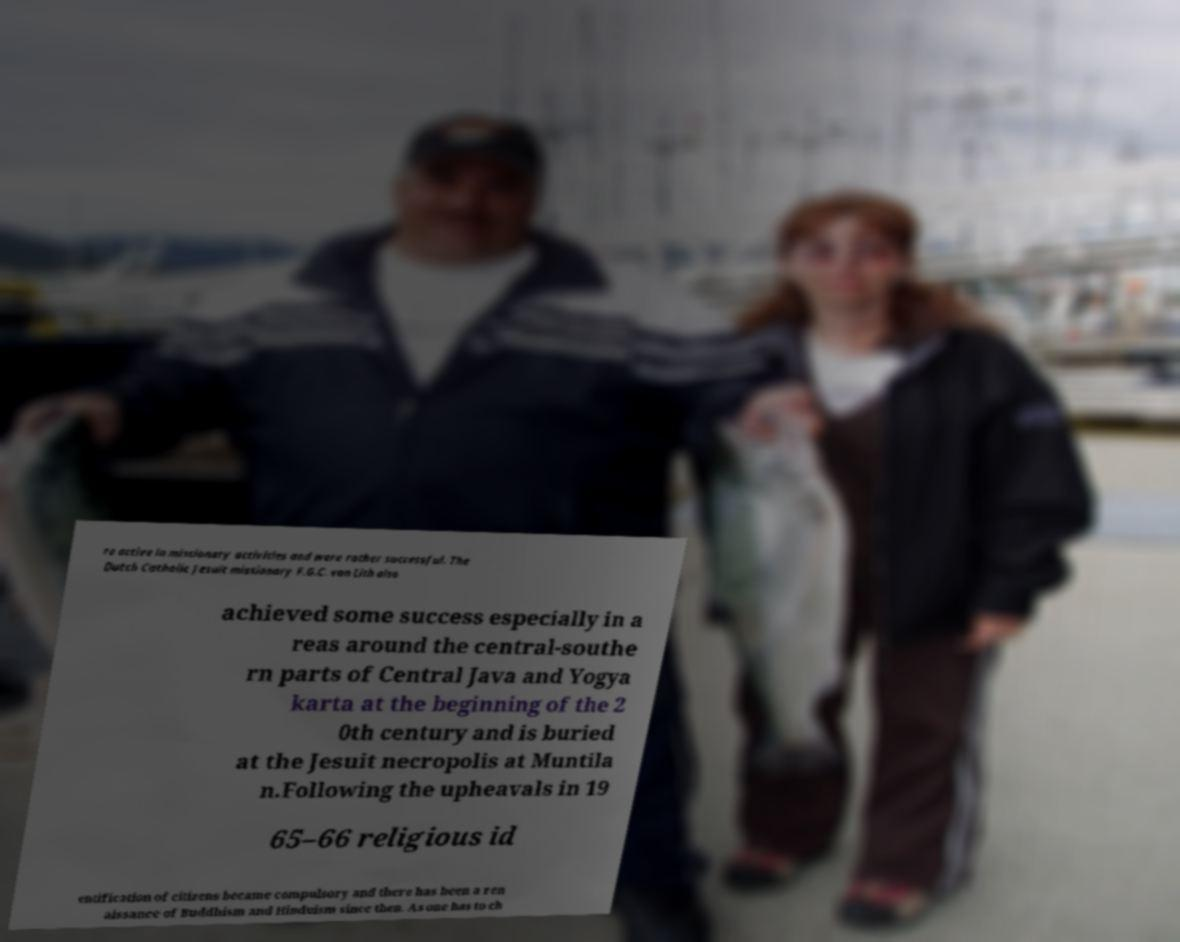Can you read and provide the text displayed in the image?This photo seems to have some interesting text. Can you extract and type it out for me? re active in missionary activities and were rather successful. The Dutch Catholic Jesuit missionary F.G.C. van Lith also achieved some success especially in a reas around the central-southe rn parts of Central Java and Yogya karta at the beginning of the 2 0th century and is buried at the Jesuit necropolis at Muntila n.Following the upheavals in 19 65–66 religious id entification of citizens became compulsory and there has been a ren aissance of Buddhism and Hinduism since then. As one has to ch 